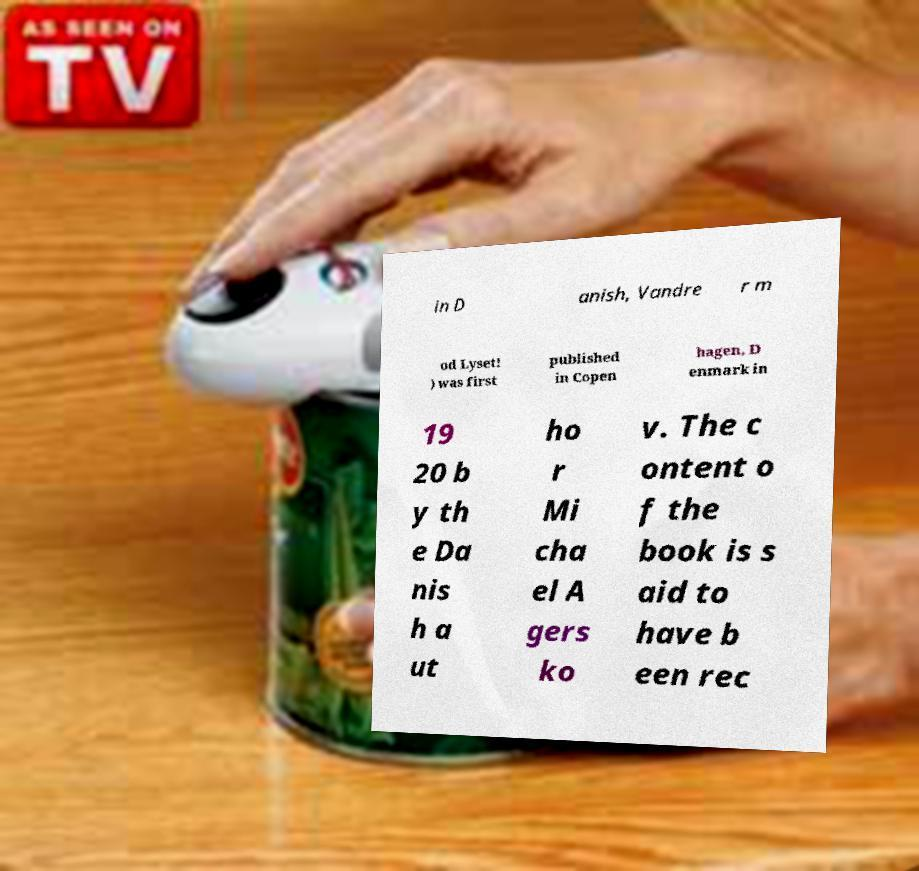Please identify and transcribe the text found in this image. in D anish, Vandre r m od Lyset! ) was first published in Copen hagen, D enmark in 19 20 b y th e Da nis h a ut ho r Mi cha el A gers ko v. The c ontent o f the book is s aid to have b een rec 